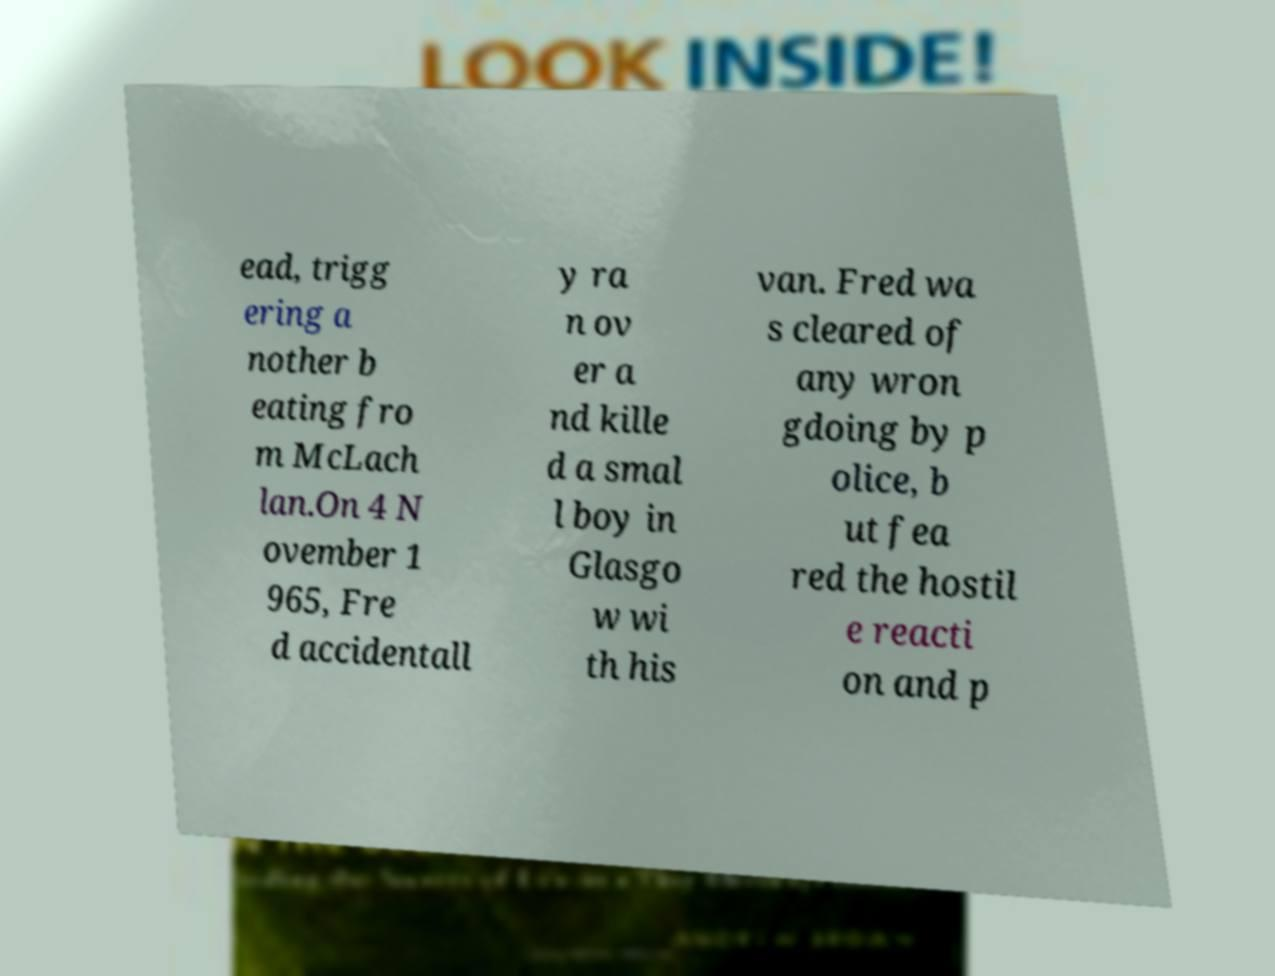There's text embedded in this image that I need extracted. Can you transcribe it verbatim? ead, trigg ering a nother b eating fro m McLach lan.On 4 N ovember 1 965, Fre d accidentall y ra n ov er a nd kille d a smal l boy in Glasgo w wi th his van. Fred wa s cleared of any wron gdoing by p olice, b ut fea red the hostil e reacti on and p 